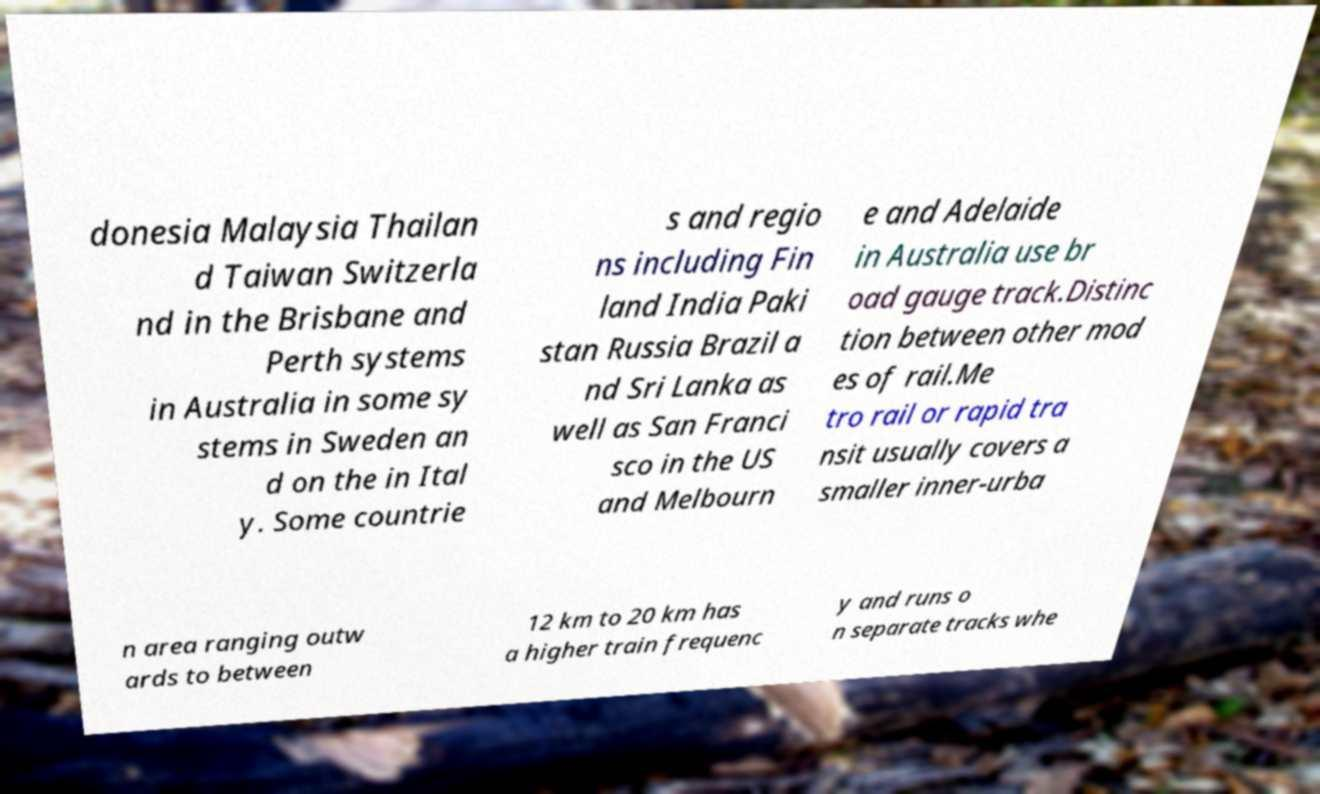What messages or text are displayed in this image? I need them in a readable, typed format. donesia Malaysia Thailan d Taiwan Switzerla nd in the Brisbane and Perth systems in Australia in some sy stems in Sweden an d on the in Ital y. Some countrie s and regio ns including Fin land India Paki stan Russia Brazil a nd Sri Lanka as well as San Franci sco in the US and Melbourn e and Adelaide in Australia use br oad gauge track.Distinc tion between other mod es of rail.Me tro rail or rapid tra nsit usually covers a smaller inner-urba n area ranging outw ards to between 12 km to 20 km has a higher train frequenc y and runs o n separate tracks whe 